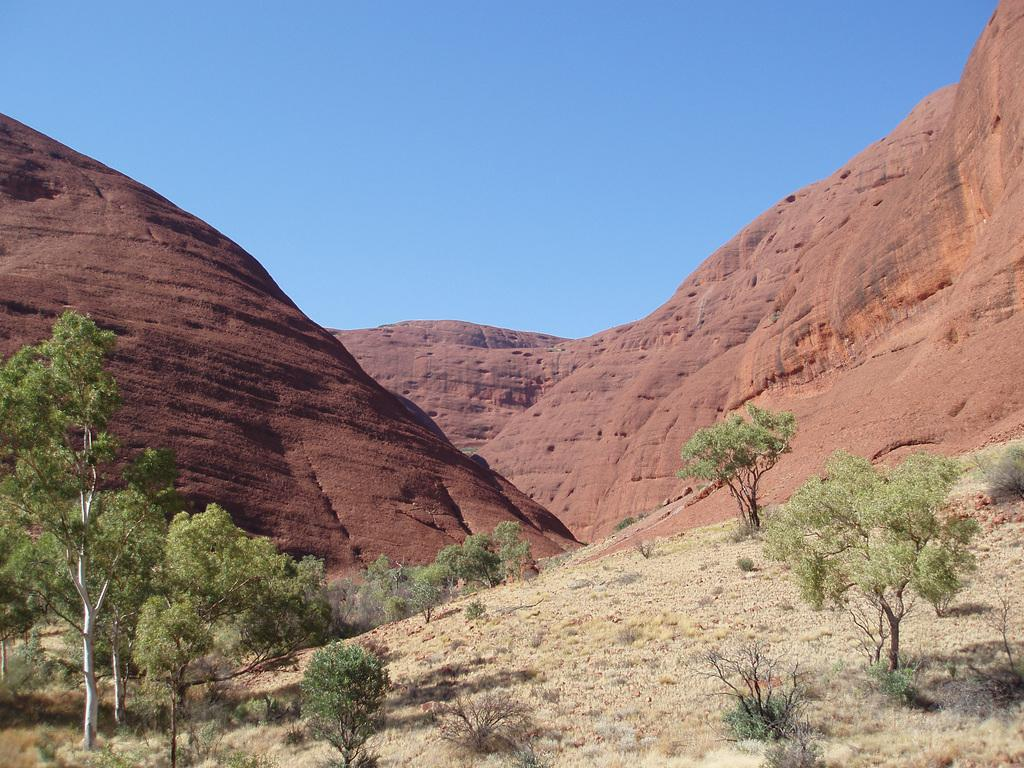What type of landscape feature is present in the image? There are hills in the image. What can be found at the bottom of the image? There are trees, plants, and grass at the bottom of the image. What is visible in the background of the image? The sky is visible in the background of the image. What is the title of the book that the dog is reading in the image? There is no dog or book present in the image. Where is the mailbox located in the image? There is no mailbox present in the image. 